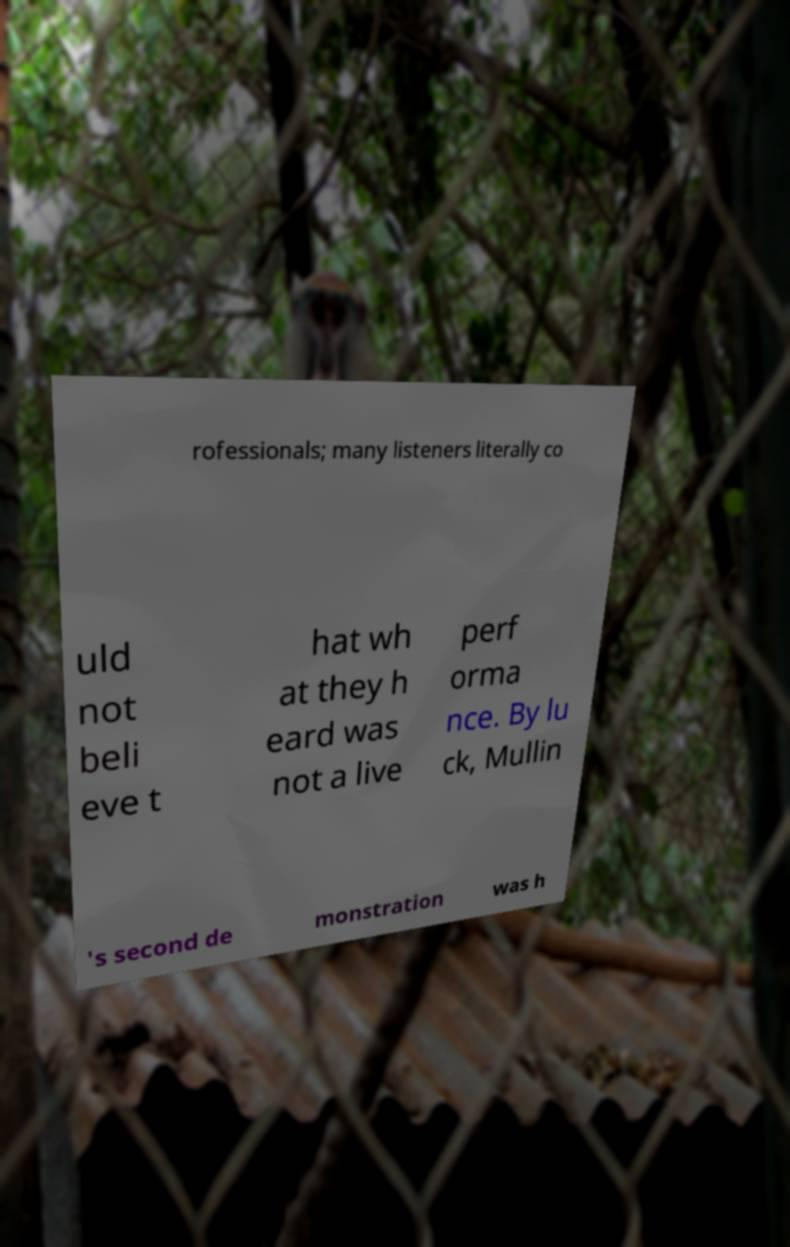I need the written content from this picture converted into text. Can you do that? rofessionals; many listeners literally co uld not beli eve t hat wh at they h eard was not a live perf orma nce. By lu ck, Mullin 's second de monstration was h 